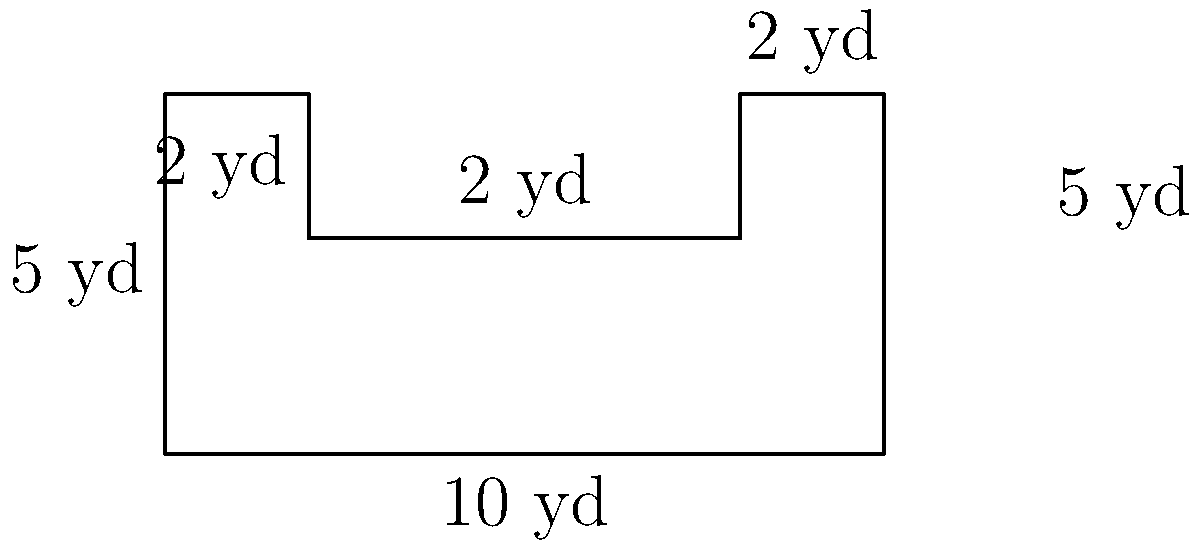As the project manager for the ACC tournament tailgating event, you're tasked with setting up a designated area for fans. The oddly-shaped tailgating area is represented in the diagram above. What is the perimeter of this tailgating area in yards? To find the perimeter, we need to add up all the sides of the shape:

1) Bottom side: $10$ yards
2) Right side: $5$ yards
3) Top-right side: $2$ yards
4) Right part of the top: $2$ yards
5) Right part of the middle section: $2$ yards
6) Left part of the middle section: $6$ yards (8 - 2 = 6)
7) Left part of the top: $2$ yards
8) Left side: $5$ yards

Now, let's add all these lengths:

$$10 + 5 + 2 + 2 + 2 + 6 + 2 + 5 = 34$$

Therefore, the perimeter of the tailgating area is 34 yards.
Answer: 34 yards 